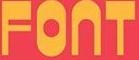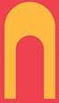Read the text content from these images in order, separated by a semicolon. FONT; N 